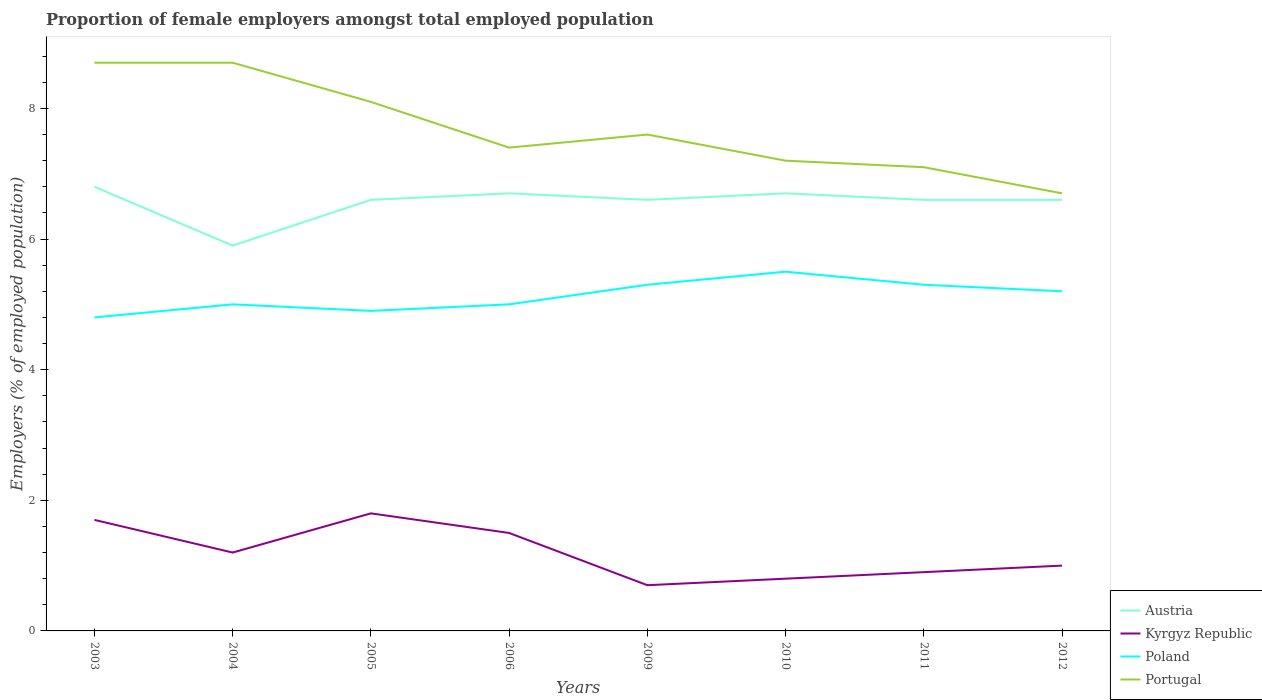Does the line corresponding to Poland intersect with the line corresponding to Austria?
Provide a succinct answer. No. Is the number of lines equal to the number of legend labels?
Make the answer very short. Yes. Across all years, what is the maximum proportion of female employers in Kyrgyz Republic?
Make the answer very short. 0.7. In which year was the proportion of female employers in Kyrgyz Republic maximum?
Offer a terse response. 2009. What is the total proportion of female employers in Poland in the graph?
Ensure brevity in your answer.  -0.3. What is the difference between the highest and the second highest proportion of female employers in Portugal?
Make the answer very short. 2. What is the difference between the highest and the lowest proportion of female employers in Kyrgyz Republic?
Your response must be concise. 4. Is the proportion of female employers in Poland strictly greater than the proportion of female employers in Kyrgyz Republic over the years?
Provide a succinct answer. No. How many years are there in the graph?
Make the answer very short. 8. What is the difference between two consecutive major ticks on the Y-axis?
Keep it short and to the point. 2. Where does the legend appear in the graph?
Provide a short and direct response. Bottom right. How are the legend labels stacked?
Offer a very short reply. Vertical. What is the title of the graph?
Your answer should be very brief. Proportion of female employers amongst total employed population. Does "Bangladesh" appear as one of the legend labels in the graph?
Keep it short and to the point. No. What is the label or title of the X-axis?
Keep it short and to the point. Years. What is the label or title of the Y-axis?
Give a very brief answer. Employers (% of employed population). What is the Employers (% of employed population) of Austria in 2003?
Ensure brevity in your answer.  6.8. What is the Employers (% of employed population) of Kyrgyz Republic in 2003?
Make the answer very short. 1.7. What is the Employers (% of employed population) of Poland in 2003?
Keep it short and to the point. 4.8. What is the Employers (% of employed population) in Portugal in 2003?
Provide a short and direct response. 8.7. What is the Employers (% of employed population) in Austria in 2004?
Make the answer very short. 5.9. What is the Employers (% of employed population) of Kyrgyz Republic in 2004?
Your answer should be compact. 1.2. What is the Employers (% of employed population) in Portugal in 2004?
Provide a succinct answer. 8.7. What is the Employers (% of employed population) in Austria in 2005?
Your response must be concise. 6.6. What is the Employers (% of employed population) of Kyrgyz Republic in 2005?
Keep it short and to the point. 1.8. What is the Employers (% of employed population) of Poland in 2005?
Offer a terse response. 4.9. What is the Employers (% of employed population) in Portugal in 2005?
Ensure brevity in your answer.  8.1. What is the Employers (% of employed population) of Austria in 2006?
Make the answer very short. 6.7. What is the Employers (% of employed population) of Kyrgyz Republic in 2006?
Provide a succinct answer. 1.5. What is the Employers (% of employed population) in Portugal in 2006?
Make the answer very short. 7.4. What is the Employers (% of employed population) in Austria in 2009?
Provide a short and direct response. 6.6. What is the Employers (% of employed population) of Kyrgyz Republic in 2009?
Your answer should be very brief. 0.7. What is the Employers (% of employed population) in Poland in 2009?
Keep it short and to the point. 5.3. What is the Employers (% of employed population) of Portugal in 2009?
Ensure brevity in your answer.  7.6. What is the Employers (% of employed population) of Austria in 2010?
Provide a short and direct response. 6.7. What is the Employers (% of employed population) of Kyrgyz Republic in 2010?
Offer a very short reply. 0.8. What is the Employers (% of employed population) in Portugal in 2010?
Provide a short and direct response. 7.2. What is the Employers (% of employed population) of Austria in 2011?
Your response must be concise. 6.6. What is the Employers (% of employed population) in Kyrgyz Republic in 2011?
Offer a terse response. 0.9. What is the Employers (% of employed population) in Poland in 2011?
Make the answer very short. 5.3. What is the Employers (% of employed population) of Portugal in 2011?
Make the answer very short. 7.1. What is the Employers (% of employed population) of Austria in 2012?
Your answer should be very brief. 6.6. What is the Employers (% of employed population) of Poland in 2012?
Your answer should be very brief. 5.2. What is the Employers (% of employed population) in Portugal in 2012?
Provide a short and direct response. 6.7. Across all years, what is the maximum Employers (% of employed population) of Austria?
Your response must be concise. 6.8. Across all years, what is the maximum Employers (% of employed population) in Kyrgyz Republic?
Make the answer very short. 1.8. Across all years, what is the maximum Employers (% of employed population) in Portugal?
Provide a short and direct response. 8.7. Across all years, what is the minimum Employers (% of employed population) of Austria?
Provide a short and direct response. 5.9. Across all years, what is the minimum Employers (% of employed population) in Kyrgyz Republic?
Your answer should be very brief. 0.7. Across all years, what is the minimum Employers (% of employed population) in Poland?
Keep it short and to the point. 4.8. Across all years, what is the minimum Employers (% of employed population) of Portugal?
Your answer should be very brief. 6.7. What is the total Employers (% of employed population) of Austria in the graph?
Your response must be concise. 52.5. What is the total Employers (% of employed population) of Poland in the graph?
Keep it short and to the point. 41. What is the total Employers (% of employed population) in Portugal in the graph?
Offer a terse response. 61.5. What is the difference between the Employers (% of employed population) in Austria in 2003 and that in 2004?
Your answer should be very brief. 0.9. What is the difference between the Employers (% of employed population) of Kyrgyz Republic in 2003 and that in 2004?
Provide a succinct answer. 0.5. What is the difference between the Employers (% of employed population) in Poland in 2003 and that in 2004?
Your response must be concise. -0.2. What is the difference between the Employers (% of employed population) of Portugal in 2003 and that in 2004?
Offer a terse response. 0. What is the difference between the Employers (% of employed population) of Kyrgyz Republic in 2003 and that in 2005?
Give a very brief answer. -0.1. What is the difference between the Employers (% of employed population) in Kyrgyz Republic in 2003 and that in 2009?
Give a very brief answer. 1. What is the difference between the Employers (% of employed population) of Poland in 2003 and that in 2009?
Your answer should be very brief. -0.5. What is the difference between the Employers (% of employed population) in Portugal in 2003 and that in 2009?
Provide a succinct answer. 1.1. What is the difference between the Employers (% of employed population) in Austria in 2003 and that in 2010?
Offer a very short reply. 0.1. What is the difference between the Employers (% of employed population) of Portugal in 2003 and that in 2010?
Your response must be concise. 1.5. What is the difference between the Employers (% of employed population) in Austria in 2003 and that in 2011?
Offer a terse response. 0.2. What is the difference between the Employers (% of employed population) in Poland in 2003 and that in 2011?
Provide a succinct answer. -0.5. What is the difference between the Employers (% of employed population) of Portugal in 2003 and that in 2011?
Keep it short and to the point. 1.6. What is the difference between the Employers (% of employed population) in Austria in 2003 and that in 2012?
Provide a short and direct response. 0.2. What is the difference between the Employers (% of employed population) in Kyrgyz Republic in 2003 and that in 2012?
Provide a short and direct response. 0.7. What is the difference between the Employers (% of employed population) of Portugal in 2003 and that in 2012?
Offer a very short reply. 2. What is the difference between the Employers (% of employed population) of Austria in 2004 and that in 2005?
Ensure brevity in your answer.  -0.7. What is the difference between the Employers (% of employed population) in Austria in 2004 and that in 2006?
Your answer should be compact. -0.8. What is the difference between the Employers (% of employed population) of Kyrgyz Republic in 2004 and that in 2006?
Your response must be concise. -0.3. What is the difference between the Employers (% of employed population) of Austria in 2004 and that in 2009?
Give a very brief answer. -0.7. What is the difference between the Employers (% of employed population) of Kyrgyz Republic in 2004 and that in 2009?
Keep it short and to the point. 0.5. What is the difference between the Employers (% of employed population) in Portugal in 2004 and that in 2010?
Your response must be concise. 1.5. What is the difference between the Employers (% of employed population) in Poland in 2004 and that in 2011?
Offer a terse response. -0.3. What is the difference between the Employers (% of employed population) of Austria in 2004 and that in 2012?
Offer a very short reply. -0.7. What is the difference between the Employers (% of employed population) of Kyrgyz Republic in 2005 and that in 2006?
Provide a short and direct response. 0.3. What is the difference between the Employers (% of employed population) of Poland in 2005 and that in 2006?
Your answer should be very brief. -0.1. What is the difference between the Employers (% of employed population) of Portugal in 2005 and that in 2006?
Provide a succinct answer. 0.7. What is the difference between the Employers (% of employed population) of Portugal in 2005 and that in 2009?
Give a very brief answer. 0.5. What is the difference between the Employers (% of employed population) of Portugal in 2005 and that in 2010?
Keep it short and to the point. 0.9. What is the difference between the Employers (% of employed population) in Austria in 2005 and that in 2011?
Make the answer very short. 0. What is the difference between the Employers (% of employed population) of Poland in 2005 and that in 2011?
Provide a succinct answer. -0.4. What is the difference between the Employers (% of employed population) of Austria in 2005 and that in 2012?
Your answer should be compact. 0. What is the difference between the Employers (% of employed population) of Poland in 2005 and that in 2012?
Provide a short and direct response. -0.3. What is the difference between the Employers (% of employed population) in Portugal in 2005 and that in 2012?
Offer a terse response. 1.4. What is the difference between the Employers (% of employed population) of Austria in 2006 and that in 2009?
Provide a succinct answer. 0.1. What is the difference between the Employers (% of employed population) of Portugal in 2006 and that in 2009?
Provide a short and direct response. -0.2. What is the difference between the Employers (% of employed population) in Austria in 2006 and that in 2010?
Your answer should be very brief. 0. What is the difference between the Employers (% of employed population) in Kyrgyz Republic in 2006 and that in 2010?
Provide a succinct answer. 0.7. What is the difference between the Employers (% of employed population) in Portugal in 2006 and that in 2010?
Provide a succinct answer. 0.2. What is the difference between the Employers (% of employed population) in Austria in 2006 and that in 2011?
Your response must be concise. 0.1. What is the difference between the Employers (% of employed population) in Portugal in 2006 and that in 2011?
Make the answer very short. 0.3. What is the difference between the Employers (% of employed population) of Kyrgyz Republic in 2006 and that in 2012?
Offer a terse response. 0.5. What is the difference between the Employers (% of employed population) in Kyrgyz Republic in 2009 and that in 2010?
Give a very brief answer. -0.1. What is the difference between the Employers (% of employed population) of Poland in 2009 and that in 2010?
Offer a terse response. -0.2. What is the difference between the Employers (% of employed population) of Austria in 2009 and that in 2011?
Your answer should be compact. 0. What is the difference between the Employers (% of employed population) in Kyrgyz Republic in 2009 and that in 2011?
Provide a short and direct response. -0.2. What is the difference between the Employers (% of employed population) in Portugal in 2009 and that in 2011?
Your answer should be compact. 0.5. What is the difference between the Employers (% of employed population) in Poland in 2010 and that in 2011?
Your answer should be very brief. 0.2. What is the difference between the Employers (% of employed population) of Portugal in 2010 and that in 2011?
Make the answer very short. 0.1. What is the difference between the Employers (% of employed population) in Austria in 2010 and that in 2012?
Make the answer very short. 0.1. What is the difference between the Employers (% of employed population) in Kyrgyz Republic in 2010 and that in 2012?
Give a very brief answer. -0.2. What is the difference between the Employers (% of employed population) of Austria in 2011 and that in 2012?
Provide a succinct answer. 0. What is the difference between the Employers (% of employed population) in Kyrgyz Republic in 2011 and that in 2012?
Provide a succinct answer. -0.1. What is the difference between the Employers (% of employed population) in Poland in 2011 and that in 2012?
Your answer should be very brief. 0.1. What is the difference between the Employers (% of employed population) in Austria in 2003 and the Employers (% of employed population) in Poland in 2004?
Your answer should be very brief. 1.8. What is the difference between the Employers (% of employed population) in Austria in 2003 and the Employers (% of employed population) in Portugal in 2004?
Give a very brief answer. -1.9. What is the difference between the Employers (% of employed population) in Kyrgyz Republic in 2003 and the Employers (% of employed population) in Poland in 2004?
Provide a short and direct response. -3.3. What is the difference between the Employers (% of employed population) in Kyrgyz Republic in 2003 and the Employers (% of employed population) in Portugal in 2004?
Offer a very short reply. -7. What is the difference between the Employers (% of employed population) in Austria in 2003 and the Employers (% of employed population) in Poland in 2005?
Give a very brief answer. 1.9. What is the difference between the Employers (% of employed population) of Austria in 2003 and the Employers (% of employed population) of Portugal in 2005?
Provide a succinct answer. -1.3. What is the difference between the Employers (% of employed population) in Kyrgyz Republic in 2003 and the Employers (% of employed population) in Poland in 2005?
Offer a very short reply. -3.2. What is the difference between the Employers (% of employed population) of Kyrgyz Republic in 2003 and the Employers (% of employed population) of Portugal in 2005?
Keep it short and to the point. -6.4. What is the difference between the Employers (% of employed population) in Austria in 2003 and the Employers (% of employed population) in Portugal in 2006?
Ensure brevity in your answer.  -0.6. What is the difference between the Employers (% of employed population) in Kyrgyz Republic in 2003 and the Employers (% of employed population) in Portugal in 2006?
Your answer should be compact. -5.7. What is the difference between the Employers (% of employed population) of Poland in 2003 and the Employers (% of employed population) of Portugal in 2006?
Give a very brief answer. -2.6. What is the difference between the Employers (% of employed population) of Austria in 2003 and the Employers (% of employed population) of Poland in 2009?
Provide a succinct answer. 1.5. What is the difference between the Employers (% of employed population) of Austria in 2003 and the Employers (% of employed population) of Portugal in 2009?
Offer a terse response. -0.8. What is the difference between the Employers (% of employed population) of Austria in 2003 and the Employers (% of employed population) of Kyrgyz Republic in 2010?
Your answer should be very brief. 6. What is the difference between the Employers (% of employed population) of Austria in 2003 and the Employers (% of employed population) of Portugal in 2010?
Offer a terse response. -0.4. What is the difference between the Employers (% of employed population) of Kyrgyz Republic in 2003 and the Employers (% of employed population) of Poland in 2011?
Ensure brevity in your answer.  -3.6. What is the difference between the Employers (% of employed population) of Poland in 2003 and the Employers (% of employed population) of Portugal in 2011?
Keep it short and to the point. -2.3. What is the difference between the Employers (% of employed population) in Austria in 2003 and the Employers (% of employed population) in Kyrgyz Republic in 2012?
Provide a succinct answer. 5.8. What is the difference between the Employers (% of employed population) in Austria in 2003 and the Employers (% of employed population) in Poland in 2012?
Your response must be concise. 1.6. What is the difference between the Employers (% of employed population) of Austria in 2003 and the Employers (% of employed population) of Portugal in 2012?
Provide a short and direct response. 0.1. What is the difference between the Employers (% of employed population) in Austria in 2004 and the Employers (% of employed population) in Kyrgyz Republic in 2005?
Make the answer very short. 4.1. What is the difference between the Employers (% of employed population) of Kyrgyz Republic in 2004 and the Employers (% of employed population) of Poland in 2005?
Provide a short and direct response. -3.7. What is the difference between the Employers (% of employed population) of Kyrgyz Republic in 2004 and the Employers (% of employed population) of Portugal in 2005?
Your answer should be very brief. -6.9. What is the difference between the Employers (% of employed population) in Austria in 2004 and the Employers (% of employed population) in Kyrgyz Republic in 2006?
Your answer should be very brief. 4.4. What is the difference between the Employers (% of employed population) in Austria in 2004 and the Employers (% of employed population) in Poland in 2006?
Offer a terse response. 0.9. What is the difference between the Employers (% of employed population) in Kyrgyz Republic in 2004 and the Employers (% of employed population) in Poland in 2006?
Provide a short and direct response. -3.8. What is the difference between the Employers (% of employed population) in Austria in 2004 and the Employers (% of employed population) in Portugal in 2009?
Your answer should be compact. -1.7. What is the difference between the Employers (% of employed population) in Kyrgyz Republic in 2004 and the Employers (% of employed population) in Poland in 2009?
Offer a very short reply. -4.1. What is the difference between the Employers (% of employed population) of Kyrgyz Republic in 2004 and the Employers (% of employed population) of Portugal in 2009?
Keep it short and to the point. -6.4. What is the difference between the Employers (% of employed population) of Poland in 2004 and the Employers (% of employed population) of Portugal in 2009?
Offer a very short reply. -2.6. What is the difference between the Employers (% of employed population) of Austria in 2004 and the Employers (% of employed population) of Kyrgyz Republic in 2010?
Your answer should be compact. 5.1. What is the difference between the Employers (% of employed population) in Austria in 2004 and the Employers (% of employed population) in Poland in 2010?
Your answer should be compact. 0.4. What is the difference between the Employers (% of employed population) in Kyrgyz Republic in 2004 and the Employers (% of employed population) in Poland in 2010?
Provide a short and direct response. -4.3. What is the difference between the Employers (% of employed population) in Kyrgyz Republic in 2004 and the Employers (% of employed population) in Portugal in 2010?
Your answer should be compact. -6. What is the difference between the Employers (% of employed population) of Poland in 2004 and the Employers (% of employed population) of Portugal in 2010?
Provide a succinct answer. -2.2. What is the difference between the Employers (% of employed population) of Austria in 2004 and the Employers (% of employed population) of Kyrgyz Republic in 2011?
Your answer should be compact. 5. What is the difference between the Employers (% of employed population) of Austria in 2004 and the Employers (% of employed population) of Poland in 2011?
Provide a succinct answer. 0.6. What is the difference between the Employers (% of employed population) in Poland in 2004 and the Employers (% of employed population) in Portugal in 2011?
Make the answer very short. -2.1. What is the difference between the Employers (% of employed population) of Austria in 2004 and the Employers (% of employed population) of Kyrgyz Republic in 2012?
Your answer should be compact. 4.9. What is the difference between the Employers (% of employed population) in Austria in 2004 and the Employers (% of employed population) in Poland in 2012?
Provide a short and direct response. 0.7. What is the difference between the Employers (% of employed population) of Kyrgyz Republic in 2004 and the Employers (% of employed population) of Poland in 2012?
Keep it short and to the point. -4. What is the difference between the Employers (% of employed population) in Poland in 2004 and the Employers (% of employed population) in Portugal in 2012?
Make the answer very short. -1.7. What is the difference between the Employers (% of employed population) of Austria in 2005 and the Employers (% of employed population) of Kyrgyz Republic in 2006?
Provide a short and direct response. 5.1. What is the difference between the Employers (% of employed population) in Austria in 2005 and the Employers (% of employed population) in Poland in 2006?
Your answer should be compact. 1.6. What is the difference between the Employers (% of employed population) in Kyrgyz Republic in 2005 and the Employers (% of employed population) in Poland in 2006?
Offer a very short reply. -3.2. What is the difference between the Employers (% of employed population) in Kyrgyz Republic in 2005 and the Employers (% of employed population) in Portugal in 2006?
Keep it short and to the point. -5.6. What is the difference between the Employers (% of employed population) in Poland in 2005 and the Employers (% of employed population) in Portugal in 2006?
Your answer should be very brief. -2.5. What is the difference between the Employers (% of employed population) in Austria in 2005 and the Employers (% of employed population) in Portugal in 2009?
Ensure brevity in your answer.  -1. What is the difference between the Employers (% of employed population) in Kyrgyz Republic in 2005 and the Employers (% of employed population) in Poland in 2009?
Your answer should be compact. -3.5. What is the difference between the Employers (% of employed population) in Kyrgyz Republic in 2005 and the Employers (% of employed population) in Portugal in 2009?
Keep it short and to the point. -5.8. What is the difference between the Employers (% of employed population) of Austria in 2005 and the Employers (% of employed population) of Poland in 2010?
Provide a short and direct response. 1.1. What is the difference between the Employers (% of employed population) in Austria in 2005 and the Employers (% of employed population) in Portugal in 2010?
Ensure brevity in your answer.  -0.6. What is the difference between the Employers (% of employed population) of Kyrgyz Republic in 2005 and the Employers (% of employed population) of Portugal in 2010?
Provide a short and direct response. -5.4. What is the difference between the Employers (% of employed population) of Poland in 2005 and the Employers (% of employed population) of Portugal in 2010?
Make the answer very short. -2.3. What is the difference between the Employers (% of employed population) in Austria in 2005 and the Employers (% of employed population) in Portugal in 2011?
Offer a very short reply. -0.5. What is the difference between the Employers (% of employed population) in Kyrgyz Republic in 2005 and the Employers (% of employed population) in Poland in 2011?
Offer a terse response. -3.5. What is the difference between the Employers (% of employed population) of Kyrgyz Republic in 2005 and the Employers (% of employed population) of Portugal in 2011?
Provide a succinct answer. -5.3. What is the difference between the Employers (% of employed population) of Poland in 2005 and the Employers (% of employed population) of Portugal in 2011?
Offer a terse response. -2.2. What is the difference between the Employers (% of employed population) in Austria in 2005 and the Employers (% of employed population) in Kyrgyz Republic in 2012?
Give a very brief answer. 5.6. What is the difference between the Employers (% of employed population) in Austria in 2005 and the Employers (% of employed population) in Poland in 2012?
Your response must be concise. 1.4. What is the difference between the Employers (% of employed population) of Poland in 2005 and the Employers (% of employed population) of Portugal in 2012?
Ensure brevity in your answer.  -1.8. What is the difference between the Employers (% of employed population) in Kyrgyz Republic in 2006 and the Employers (% of employed population) in Poland in 2009?
Make the answer very short. -3.8. What is the difference between the Employers (% of employed population) of Kyrgyz Republic in 2006 and the Employers (% of employed population) of Portugal in 2009?
Provide a succinct answer. -6.1. What is the difference between the Employers (% of employed population) in Kyrgyz Republic in 2006 and the Employers (% of employed population) in Poland in 2010?
Ensure brevity in your answer.  -4. What is the difference between the Employers (% of employed population) in Kyrgyz Republic in 2006 and the Employers (% of employed population) in Portugal in 2010?
Your answer should be compact. -5.7. What is the difference between the Employers (% of employed population) of Poland in 2006 and the Employers (% of employed population) of Portugal in 2010?
Offer a very short reply. -2.2. What is the difference between the Employers (% of employed population) of Austria in 2006 and the Employers (% of employed population) of Poland in 2011?
Provide a short and direct response. 1.4. What is the difference between the Employers (% of employed population) in Austria in 2006 and the Employers (% of employed population) in Portugal in 2011?
Your answer should be compact. -0.4. What is the difference between the Employers (% of employed population) of Austria in 2006 and the Employers (% of employed population) of Portugal in 2012?
Make the answer very short. 0. What is the difference between the Employers (% of employed population) of Kyrgyz Republic in 2006 and the Employers (% of employed population) of Poland in 2012?
Make the answer very short. -3.7. What is the difference between the Employers (% of employed population) in Kyrgyz Republic in 2006 and the Employers (% of employed population) in Portugal in 2012?
Your response must be concise. -5.2. What is the difference between the Employers (% of employed population) of Poland in 2006 and the Employers (% of employed population) of Portugal in 2012?
Keep it short and to the point. -1.7. What is the difference between the Employers (% of employed population) of Austria in 2009 and the Employers (% of employed population) of Kyrgyz Republic in 2010?
Ensure brevity in your answer.  5.8. What is the difference between the Employers (% of employed population) in Kyrgyz Republic in 2009 and the Employers (% of employed population) in Poland in 2010?
Ensure brevity in your answer.  -4.8. What is the difference between the Employers (% of employed population) in Kyrgyz Republic in 2009 and the Employers (% of employed population) in Portugal in 2010?
Your answer should be compact. -6.5. What is the difference between the Employers (% of employed population) of Austria in 2009 and the Employers (% of employed population) of Kyrgyz Republic in 2011?
Keep it short and to the point. 5.7. What is the difference between the Employers (% of employed population) in Austria in 2009 and the Employers (% of employed population) in Poland in 2011?
Your answer should be compact. 1.3. What is the difference between the Employers (% of employed population) in Austria in 2009 and the Employers (% of employed population) in Portugal in 2011?
Your answer should be compact. -0.5. What is the difference between the Employers (% of employed population) in Kyrgyz Republic in 2009 and the Employers (% of employed population) in Portugal in 2011?
Provide a short and direct response. -6.4. What is the difference between the Employers (% of employed population) of Poland in 2009 and the Employers (% of employed population) of Portugal in 2011?
Give a very brief answer. -1.8. What is the difference between the Employers (% of employed population) of Austria in 2009 and the Employers (% of employed population) of Kyrgyz Republic in 2012?
Make the answer very short. 5.6. What is the difference between the Employers (% of employed population) of Austria in 2009 and the Employers (% of employed population) of Portugal in 2012?
Offer a terse response. -0.1. What is the difference between the Employers (% of employed population) of Poland in 2009 and the Employers (% of employed population) of Portugal in 2012?
Your response must be concise. -1.4. What is the difference between the Employers (% of employed population) of Austria in 2010 and the Employers (% of employed population) of Kyrgyz Republic in 2011?
Make the answer very short. 5.8. What is the difference between the Employers (% of employed population) in Austria in 2010 and the Employers (% of employed population) in Poland in 2011?
Give a very brief answer. 1.4. What is the difference between the Employers (% of employed population) of Kyrgyz Republic in 2010 and the Employers (% of employed population) of Portugal in 2011?
Your response must be concise. -6.3. What is the difference between the Employers (% of employed population) of Poland in 2010 and the Employers (% of employed population) of Portugal in 2011?
Provide a succinct answer. -1.6. What is the difference between the Employers (% of employed population) of Austria in 2010 and the Employers (% of employed population) of Poland in 2012?
Give a very brief answer. 1.5. What is the difference between the Employers (% of employed population) of Kyrgyz Republic in 2010 and the Employers (% of employed population) of Portugal in 2012?
Provide a short and direct response. -5.9. What is the difference between the Employers (% of employed population) in Poland in 2010 and the Employers (% of employed population) in Portugal in 2012?
Provide a succinct answer. -1.2. What is the difference between the Employers (% of employed population) in Austria in 2011 and the Employers (% of employed population) in Poland in 2012?
Your answer should be compact. 1.4. What is the difference between the Employers (% of employed population) in Austria in 2011 and the Employers (% of employed population) in Portugal in 2012?
Provide a succinct answer. -0.1. What is the difference between the Employers (% of employed population) in Kyrgyz Republic in 2011 and the Employers (% of employed population) in Poland in 2012?
Keep it short and to the point. -4.3. What is the difference between the Employers (% of employed population) in Poland in 2011 and the Employers (% of employed population) in Portugal in 2012?
Give a very brief answer. -1.4. What is the average Employers (% of employed population) of Austria per year?
Provide a succinct answer. 6.56. What is the average Employers (% of employed population) of Poland per year?
Give a very brief answer. 5.12. What is the average Employers (% of employed population) in Portugal per year?
Your response must be concise. 7.69. In the year 2003, what is the difference between the Employers (% of employed population) of Austria and Employers (% of employed population) of Poland?
Your response must be concise. 2. In the year 2003, what is the difference between the Employers (% of employed population) of Austria and Employers (% of employed population) of Portugal?
Make the answer very short. -1.9. In the year 2004, what is the difference between the Employers (% of employed population) in Austria and Employers (% of employed population) in Kyrgyz Republic?
Keep it short and to the point. 4.7. In the year 2004, what is the difference between the Employers (% of employed population) in Austria and Employers (% of employed population) in Poland?
Provide a succinct answer. 0.9. In the year 2004, what is the difference between the Employers (% of employed population) in Austria and Employers (% of employed population) in Portugal?
Provide a short and direct response. -2.8. In the year 2004, what is the difference between the Employers (% of employed population) in Poland and Employers (% of employed population) in Portugal?
Your response must be concise. -3.7. In the year 2005, what is the difference between the Employers (% of employed population) of Austria and Employers (% of employed population) of Portugal?
Ensure brevity in your answer.  -1.5. In the year 2006, what is the difference between the Employers (% of employed population) of Austria and Employers (% of employed population) of Portugal?
Make the answer very short. -0.7. In the year 2006, what is the difference between the Employers (% of employed population) of Kyrgyz Republic and Employers (% of employed population) of Poland?
Your answer should be compact. -3.5. In the year 2006, what is the difference between the Employers (% of employed population) of Poland and Employers (% of employed population) of Portugal?
Offer a terse response. -2.4. In the year 2009, what is the difference between the Employers (% of employed population) of Austria and Employers (% of employed population) of Portugal?
Keep it short and to the point. -1. In the year 2010, what is the difference between the Employers (% of employed population) in Austria and Employers (% of employed population) in Kyrgyz Republic?
Your answer should be very brief. 5.9. In the year 2010, what is the difference between the Employers (% of employed population) of Austria and Employers (% of employed population) of Poland?
Offer a terse response. 1.2. In the year 2010, what is the difference between the Employers (% of employed population) of Austria and Employers (% of employed population) of Portugal?
Give a very brief answer. -0.5. In the year 2010, what is the difference between the Employers (% of employed population) in Kyrgyz Republic and Employers (% of employed population) in Poland?
Keep it short and to the point. -4.7. In the year 2010, what is the difference between the Employers (% of employed population) in Poland and Employers (% of employed population) in Portugal?
Give a very brief answer. -1.7. In the year 2011, what is the difference between the Employers (% of employed population) in Austria and Employers (% of employed population) in Kyrgyz Republic?
Your answer should be compact. 5.7. In the year 2011, what is the difference between the Employers (% of employed population) of Austria and Employers (% of employed population) of Portugal?
Make the answer very short. -0.5. In the year 2011, what is the difference between the Employers (% of employed population) in Poland and Employers (% of employed population) in Portugal?
Offer a very short reply. -1.8. In the year 2012, what is the difference between the Employers (% of employed population) of Austria and Employers (% of employed population) of Portugal?
Provide a short and direct response. -0.1. In the year 2012, what is the difference between the Employers (% of employed population) of Kyrgyz Republic and Employers (% of employed population) of Portugal?
Keep it short and to the point. -5.7. What is the ratio of the Employers (% of employed population) of Austria in 2003 to that in 2004?
Provide a short and direct response. 1.15. What is the ratio of the Employers (% of employed population) of Kyrgyz Republic in 2003 to that in 2004?
Your response must be concise. 1.42. What is the ratio of the Employers (% of employed population) in Portugal in 2003 to that in 2004?
Ensure brevity in your answer.  1. What is the ratio of the Employers (% of employed population) in Austria in 2003 to that in 2005?
Give a very brief answer. 1.03. What is the ratio of the Employers (% of employed population) of Poland in 2003 to that in 2005?
Offer a terse response. 0.98. What is the ratio of the Employers (% of employed population) of Portugal in 2003 to that in 2005?
Provide a short and direct response. 1.07. What is the ratio of the Employers (% of employed population) in Austria in 2003 to that in 2006?
Ensure brevity in your answer.  1.01. What is the ratio of the Employers (% of employed population) in Kyrgyz Republic in 2003 to that in 2006?
Your response must be concise. 1.13. What is the ratio of the Employers (% of employed population) of Portugal in 2003 to that in 2006?
Your response must be concise. 1.18. What is the ratio of the Employers (% of employed population) of Austria in 2003 to that in 2009?
Offer a very short reply. 1.03. What is the ratio of the Employers (% of employed population) of Kyrgyz Republic in 2003 to that in 2009?
Your response must be concise. 2.43. What is the ratio of the Employers (% of employed population) of Poland in 2003 to that in 2009?
Provide a succinct answer. 0.91. What is the ratio of the Employers (% of employed population) in Portugal in 2003 to that in 2009?
Offer a very short reply. 1.14. What is the ratio of the Employers (% of employed population) of Austria in 2003 to that in 2010?
Make the answer very short. 1.01. What is the ratio of the Employers (% of employed population) in Kyrgyz Republic in 2003 to that in 2010?
Offer a terse response. 2.12. What is the ratio of the Employers (% of employed population) of Poland in 2003 to that in 2010?
Make the answer very short. 0.87. What is the ratio of the Employers (% of employed population) in Portugal in 2003 to that in 2010?
Offer a terse response. 1.21. What is the ratio of the Employers (% of employed population) in Austria in 2003 to that in 2011?
Offer a very short reply. 1.03. What is the ratio of the Employers (% of employed population) of Kyrgyz Republic in 2003 to that in 2011?
Your answer should be very brief. 1.89. What is the ratio of the Employers (% of employed population) in Poland in 2003 to that in 2011?
Ensure brevity in your answer.  0.91. What is the ratio of the Employers (% of employed population) in Portugal in 2003 to that in 2011?
Your answer should be very brief. 1.23. What is the ratio of the Employers (% of employed population) of Austria in 2003 to that in 2012?
Make the answer very short. 1.03. What is the ratio of the Employers (% of employed population) of Portugal in 2003 to that in 2012?
Provide a succinct answer. 1.3. What is the ratio of the Employers (% of employed population) in Austria in 2004 to that in 2005?
Offer a terse response. 0.89. What is the ratio of the Employers (% of employed population) of Kyrgyz Republic in 2004 to that in 2005?
Offer a terse response. 0.67. What is the ratio of the Employers (% of employed population) of Poland in 2004 to that in 2005?
Keep it short and to the point. 1.02. What is the ratio of the Employers (% of employed population) of Portugal in 2004 to that in 2005?
Offer a very short reply. 1.07. What is the ratio of the Employers (% of employed population) of Austria in 2004 to that in 2006?
Offer a terse response. 0.88. What is the ratio of the Employers (% of employed population) of Kyrgyz Republic in 2004 to that in 2006?
Keep it short and to the point. 0.8. What is the ratio of the Employers (% of employed population) in Poland in 2004 to that in 2006?
Your answer should be compact. 1. What is the ratio of the Employers (% of employed population) of Portugal in 2004 to that in 2006?
Make the answer very short. 1.18. What is the ratio of the Employers (% of employed population) in Austria in 2004 to that in 2009?
Keep it short and to the point. 0.89. What is the ratio of the Employers (% of employed population) in Kyrgyz Republic in 2004 to that in 2009?
Your answer should be compact. 1.71. What is the ratio of the Employers (% of employed population) of Poland in 2004 to that in 2009?
Provide a succinct answer. 0.94. What is the ratio of the Employers (% of employed population) of Portugal in 2004 to that in 2009?
Provide a succinct answer. 1.14. What is the ratio of the Employers (% of employed population) of Austria in 2004 to that in 2010?
Offer a terse response. 0.88. What is the ratio of the Employers (% of employed population) in Portugal in 2004 to that in 2010?
Ensure brevity in your answer.  1.21. What is the ratio of the Employers (% of employed population) in Austria in 2004 to that in 2011?
Ensure brevity in your answer.  0.89. What is the ratio of the Employers (% of employed population) in Kyrgyz Republic in 2004 to that in 2011?
Your answer should be very brief. 1.33. What is the ratio of the Employers (% of employed population) in Poland in 2004 to that in 2011?
Your response must be concise. 0.94. What is the ratio of the Employers (% of employed population) in Portugal in 2004 to that in 2011?
Your response must be concise. 1.23. What is the ratio of the Employers (% of employed population) in Austria in 2004 to that in 2012?
Your answer should be compact. 0.89. What is the ratio of the Employers (% of employed population) of Kyrgyz Republic in 2004 to that in 2012?
Offer a very short reply. 1.2. What is the ratio of the Employers (% of employed population) in Poland in 2004 to that in 2012?
Offer a terse response. 0.96. What is the ratio of the Employers (% of employed population) of Portugal in 2004 to that in 2012?
Make the answer very short. 1.3. What is the ratio of the Employers (% of employed population) in Austria in 2005 to that in 2006?
Ensure brevity in your answer.  0.99. What is the ratio of the Employers (% of employed population) in Kyrgyz Republic in 2005 to that in 2006?
Your answer should be compact. 1.2. What is the ratio of the Employers (% of employed population) in Poland in 2005 to that in 2006?
Offer a terse response. 0.98. What is the ratio of the Employers (% of employed population) of Portugal in 2005 to that in 2006?
Your answer should be very brief. 1.09. What is the ratio of the Employers (% of employed population) of Austria in 2005 to that in 2009?
Offer a terse response. 1. What is the ratio of the Employers (% of employed population) in Kyrgyz Republic in 2005 to that in 2009?
Your answer should be very brief. 2.57. What is the ratio of the Employers (% of employed population) in Poland in 2005 to that in 2009?
Provide a succinct answer. 0.92. What is the ratio of the Employers (% of employed population) of Portugal in 2005 to that in 2009?
Your answer should be very brief. 1.07. What is the ratio of the Employers (% of employed population) in Austria in 2005 to that in 2010?
Give a very brief answer. 0.99. What is the ratio of the Employers (% of employed population) of Kyrgyz Republic in 2005 to that in 2010?
Keep it short and to the point. 2.25. What is the ratio of the Employers (% of employed population) in Poland in 2005 to that in 2010?
Ensure brevity in your answer.  0.89. What is the ratio of the Employers (% of employed population) of Poland in 2005 to that in 2011?
Keep it short and to the point. 0.92. What is the ratio of the Employers (% of employed population) of Portugal in 2005 to that in 2011?
Provide a succinct answer. 1.14. What is the ratio of the Employers (% of employed population) of Poland in 2005 to that in 2012?
Ensure brevity in your answer.  0.94. What is the ratio of the Employers (% of employed population) of Portugal in 2005 to that in 2012?
Your answer should be very brief. 1.21. What is the ratio of the Employers (% of employed population) in Austria in 2006 to that in 2009?
Provide a succinct answer. 1.02. What is the ratio of the Employers (% of employed population) in Kyrgyz Republic in 2006 to that in 2009?
Give a very brief answer. 2.14. What is the ratio of the Employers (% of employed population) of Poland in 2006 to that in 2009?
Provide a succinct answer. 0.94. What is the ratio of the Employers (% of employed population) of Portugal in 2006 to that in 2009?
Your answer should be very brief. 0.97. What is the ratio of the Employers (% of employed population) of Austria in 2006 to that in 2010?
Your response must be concise. 1. What is the ratio of the Employers (% of employed population) of Kyrgyz Republic in 2006 to that in 2010?
Your answer should be compact. 1.88. What is the ratio of the Employers (% of employed population) of Portugal in 2006 to that in 2010?
Your answer should be very brief. 1.03. What is the ratio of the Employers (% of employed population) of Austria in 2006 to that in 2011?
Your answer should be very brief. 1.02. What is the ratio of the Employers (% of employed population) in Kyrgyz Republic in 2006 to that in 2011?
Keep it short and to the point. 1.67. What is the ratio of the Employers (% of employed population) in Poland in 2006 to that in 2011?
Provide a short and direct response. 0.94. What is the ratio of the Employers (% of employed population) of Portugal in 2006 to that in 2011?
Provide a short and direct response. 1.04. What is the ratio of the Employers (% of employed population) in Austria in 2006 to that in 2012?
Your answer should be compact. 1.02. What is the ratio of the Employers (% of employed population) of Kyrgyz Republic in 2006 to that in 2012?
Your answer should be compact. 1.5. What is the ratio of the Employers (% of employed population) of Poland in 2006 to that in 2012?
Make the answer very short. 0.96. What is the ratio of the Employers (% of employed population) in Portugal in 2006 to that in 2012?
Offer a terse response. 1.1. What is the ratio of the Employers (% of employed population) in Austria in 2009 to that in 2010?
Offer a very short reply. 0.99. What is the ratio of the Employers (% of employed population) in Poland in 2009 to that in 2010?
Your answer should be very brief. 0.96. What is the ratio of the Employers (% of employed population) in Portugal in 2009 to that in 2010?
Offer a terse response. 1.06. What is the ratio of the Employers (% of employed population) in Austria in 2009 to that in 2011?
Offer a very short reply. 1. What is the ratio of the Employers (% of employed population) in Poland in 2009 to that in 2011?
Your answer should be compact. 1. What is the ratio of the Employers (% of employed population) of Portugal in 2009 to that in 2011?
Keep it short and to the point. 1.07. What is the ratio of the Employers (% of employed population) in Kyrgyz Republic in 2009 to that in 2012?
Offer a very short reply. 0.7. What is the ratio of the Employers (% of employed population) of Poland in 2009 to that in 2012?
Make the answer very short. 1.02. What is the ratio of the Employers (% of employed population) of Portugal in 2009 to that in 2012?
Provide a succinct answer. 1.13. What is the ratio of the Employers (% of employed population) in Austria in 2010 to that in 2011?
Give a very brief answer. 1.02. What is the ratio of the Employers (% of employed population) of Kyrgyz Republic in 2010 to that in 2011?
Your answer should be compact. 0.89. What is the ratio of the Employers (% of employed population) in Poland in 2010 to that in 2011?
Provide a short and direct response. 1.04. What is the ratio of the Employers (% of employed population) in Portugal in 2010 to that in 2011?
Offer a terse response. 1.01. What is the ratio of the Employers (% of employed population) in Austria in 2010 to that in 2012?
Make the answer very short. 1.02. What is the ratio of the Employers (% of employed population) in Poland in 2010 to that in 2012?
Provide a succinct answer. 1.06. What is the ratio of the Employers (% of employed population) of Portugal in 2010 to that in 2012?
Provide a short and direct response. 1.07. What is the ratio of the Employers (% of employed population) of Kyrgyz Republic in 2011 to that in 2012?
Offer a terse response. 0.9. What is the ratio of the Employers (% of employed population) of Poland in 2011 to that in 2012?
Your answer should be compact. 1.02. What is the ratio of the Employers (% of employed population) of Portugal in 2011 to that in 2012?
Your answer should be very brief. 1.06. What is the difference between the highest and the second highest Employers (% of employed population) in Austria?
Provide a short and direct response. 0.1. What is the difference between the highest and the lowest Employers (% of employed population) in Austria?
Provide a short and direct response. 0.9. What is the difference between the highest and the lowest Employers (% of employed population) of Kyrgyz Republic?
Ensure brevity in your answer.  1.1. What is the difference between the highest and the lowest Employers (% of employed population) in Poland?
Make the answer very short. 0.7. 